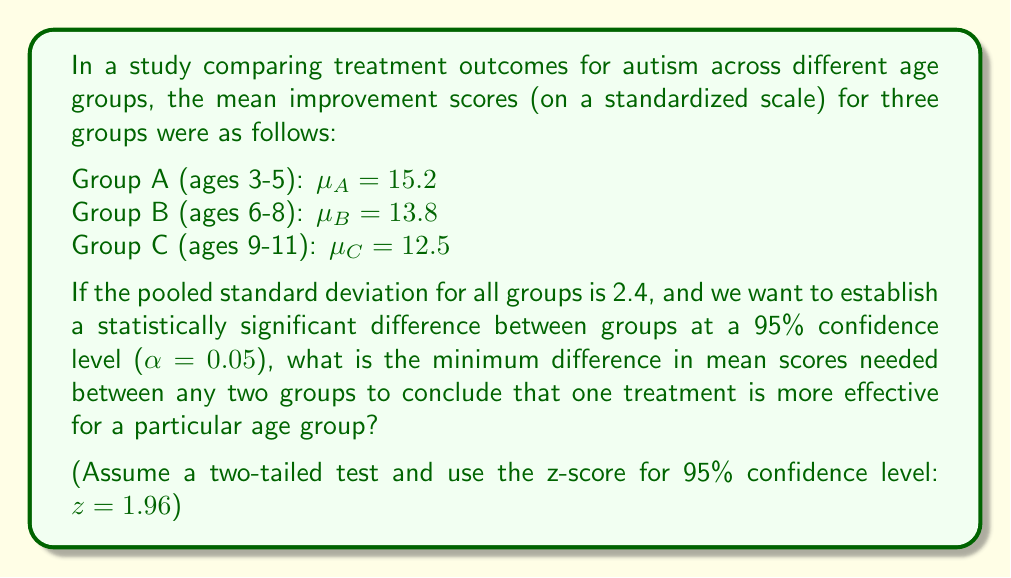Provide a solution to this math problem. To determine the minimum difference in mean scores needed for statistical significance, we need to calculate the minimum detectable effect size using the formula for comparing two independent means:

1) The formula for the minimum detectable difference (MDD) is:

   $$MDD = z \cdot \sqrt{2} \cdot \frac{\sigma}{\sqrt{n}}$$

   Where:
   - z is the z-score for the desired confidence level
   - σ is the pooled standard deviation
   - n is the sample size per group

2) We're given:
   - z = 1.96 (for 95% confidence level)
   - σ = 2.4 (pooled standard deviation)

3) We're not given the sample size (n), but we can leave it as a variable in our equation:

   $$MDD = 1.96 \cdot \sqrt{2} \cdot \frac{2.4}{\sqrt{n}}$$

4) Simplifying:

   $$MDD = 1.96 \cdot 1.414 \cdot \frac{2.4}{\sqrt{n}} = \frac{6.65}{\sqrt{n}}$$

5) This equation gives us the minimum difference needed between any two group means to conclude statistical significance at the 95% confidence level.

6) Note that as n increases, the MDD decreases, allowing for detection of smaller differences between groups.

7) For example, if n = 30 for each group:

   $$MDD = \frac{6.65}{\sqrt{30}} = 1.21$$

   This means we would need a difference of at least 1.21 between any two group means to conclude statistical significance.

8) Comparing to our given means:
   $\mu_A - \mu_B = 15.2 - 13.8 = 1.4$
   $\mu_A - \mu_C = 15.2 - 12.5 = 2.7$
   $\mu_B - \mu_C = 13.8 - 12.5 = 1.3$

   With n = 30, we could conclude that there's a significant difference between groups A and C, but not necessarily between A and B or B and C.
Answer: $\frac{6.65}{\sqrt{n}}$, where n is the sample size per group 